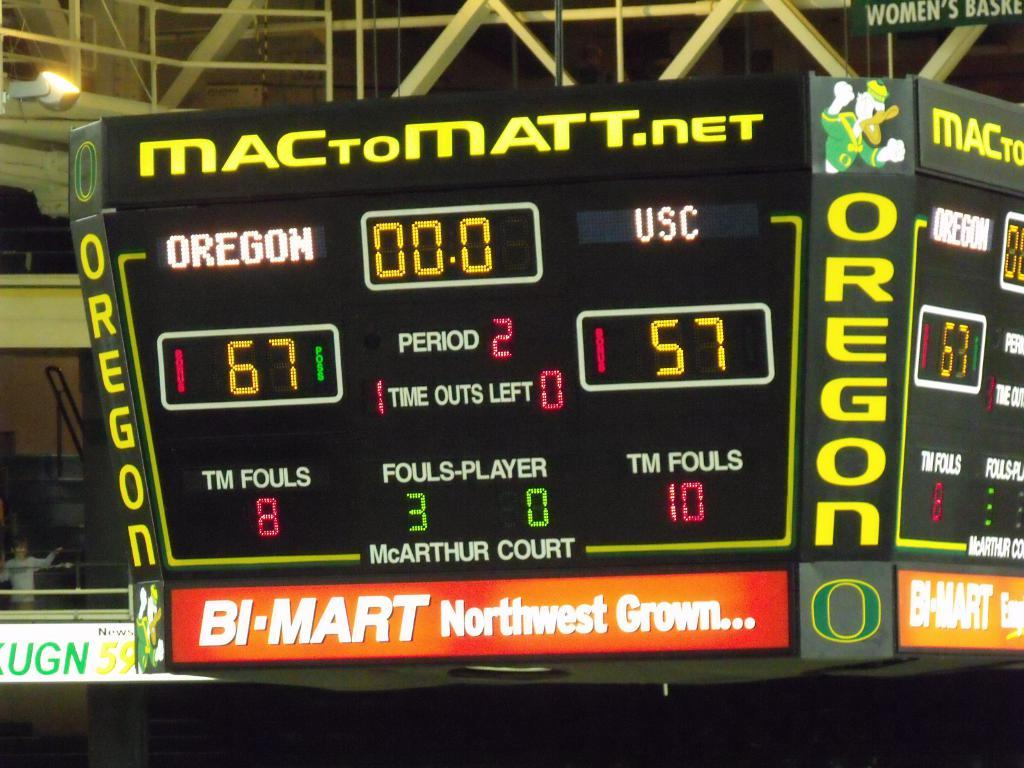Provide a one-sentence caption for the provided image. A large scoreboard shows that Oregon is beating USC, with a score of 67 to 57. 